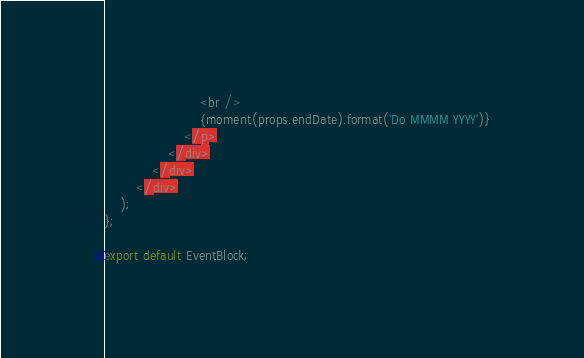<code> <loc_0><loc_0><loc_500><loc_500><_TypeScript_>						<br />
						{moment(props.endDate).format('Do MMMM YYYY')}
					</p>
				</div>
			</div>
		</div>
	);
};

export default EventBlock;
</code> 